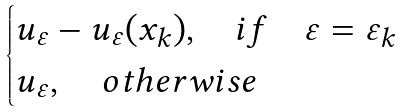<formula> <loc_0><loc_0><loc_500><loc_500>\begin{cases} u _ { \varepsilon } - u _ { \varepsilon } ( x _ { k } ) , \quad i f \quad \varepsilon = \varepsilon _ { k } \\ u _ { \varepsilon } , \quad o t h e r w i s e \end{cases}</formula> 